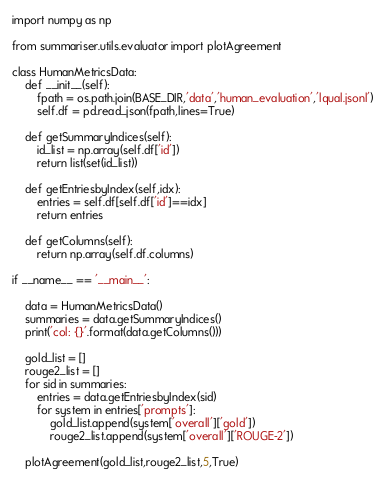<code> <loc_0><loc_0><loc_500><loc_500><_Python_>import numpy as np

from summariser.utils.evaluator import plotAgreement

class HumanMetricsData:
    def __init__(self):
        fpath = os.path.join(BASE_DIR,'data','human_evaluation','lqual.jsonl')
        self.df = pd.read_json(fpath,lines=True)

    def getSummaryIndices(self):
        id_list = np.array(self.df['id'])
        return list(set(id_list))

    def getEntriesbyIndex(self,idx):
        entries = self.df[self.df['id']==idx]
        return entries

    def getColumns(self):
        return np.array(self.df.columns)

if __name__ == '__main__':

    data = HumanMetricsData()
    summaries = data.getSummaryIndices()
    print('col: {}'.format(data.getColumns()))

    gold_list = []
    rouge2_list = []
    for sid in summaries:
        entries = data.getEntriesbyIndex(sid)
        for system in entries['prompts']:
            gold_list.append(system['overall']['gold'])
            rouge2_list.append(system['overall']['ROUGE-2'])

    plotAgreement(gold_list,rouge2_list,5,True)


</code> 